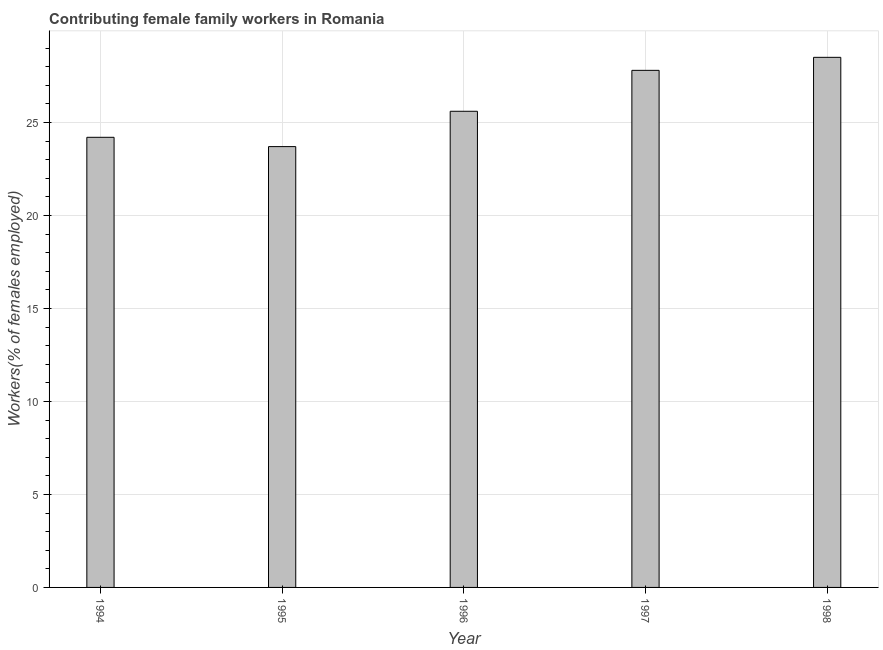What is the title of the graph?
Your answer should be compact. Contributing female family workers in Romania. What is the label or title of the X-axis?
Provide a succinct answer. Year. What is the label or title of the Y-axis?
Provide a succinct answer. Workers(% of females employed). What is the contributing female family workers in 1998?
Ensure brevity in your answer.  28.5. Across all years, what is the minimum contributing female family workers?
Make the answer very short. 23.7. What is the sum of the contributing female family workers?
Keep it short and to the point. 129.8. What is the average contributing female family workers per year?
Your answer should be compact. 25.96. What is the median contributing female family workers?
Provide a short and direct response. 25.6. What is the ratio of the contributing female family workers in 1994 to that in 1998?
Provide a short and direct response. 0.85. Is the difference between the contributing female family workers in 1994 and 1998 greater than the difference between any two years?
Give a very brief answer. No. What is the difference between the highest and the second highest contributing female family workers?
Offer a very short reply. 0.7. What is the difference between the highest and the lowest contributing female family workers?
Offer a very short reply. 4.8. How many years are there in the graph?
Your answer should be compact. 5. What is the Workers(% of females employed) of 1994?
Your answer should be very brief. 24.2. What is the Workers(% of females employed) in 1995?
Your response must be concise. 23.7. What is the Workers(% of females employed) of 1996?
Ensure brevity in your answer.  25.6. What is the Workers(% of females employed) of 1997?
Give a very brief answer. 27.8. What is the difference between the Workers(% of females employed) in 1994 and 1995?
Keep it short and to the point. 0.5. What is the difference between the Workers(% of females employed) in 1994 and 1998?
Your answer should be compact. -4.3. What is the difference between the Workers(% of females employed) in 1996 and 1997?
Give a very brief answer. -2.2. What is the difference between the Workers(% of females employed) in 1996 and 1998?
Offer a terse response. -2.9. What is the ratio of the Workers(% of females employed) in 1994 to that in 1996?
Your response must be concise. 0.94. What is the ratio of the Workers(% of females employed) in 1994 to that in 1997?
Ensure brevity in your answer.  0.87. What is the ratio of the Workers(% of females employed) in 1994 to that in 1998?
Your response must be concise. 0.85. What is the ratio of the Workers(% of females employed) in 1995 to that in 1996?
Your answer should be very brief. 0.93. What is the ratio of the Workers(% of females employed) in 1995 to that in 1997?
Offer a very short reply. 0.85. What is the ratio of the Workers(% of females employed) in 1995 to that in 1998?
Your response must be concise. 0.83. What is the ratio of the Workers(% of females employed) in 1996 to that in 1997?
Make the answer very short. 0.92. What is the ratio of the Workers(% of females employed) in 1996 to that in 1998?
Offer a terse response. 0.9. 